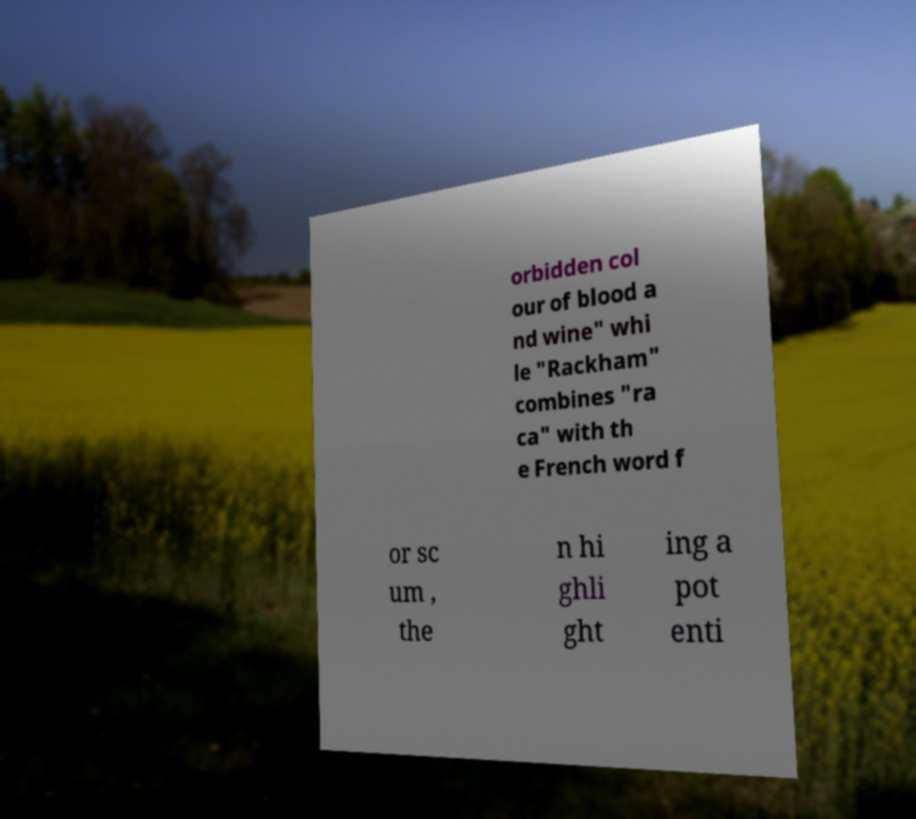What messages or text are displayed in this image? I need them in a readable, typed format. orbidden col our of blood a nd wine" whi le "Rackham" combines "ra ca" with th e French word f or sc um , the n hi ghli ght ing a pot enti 